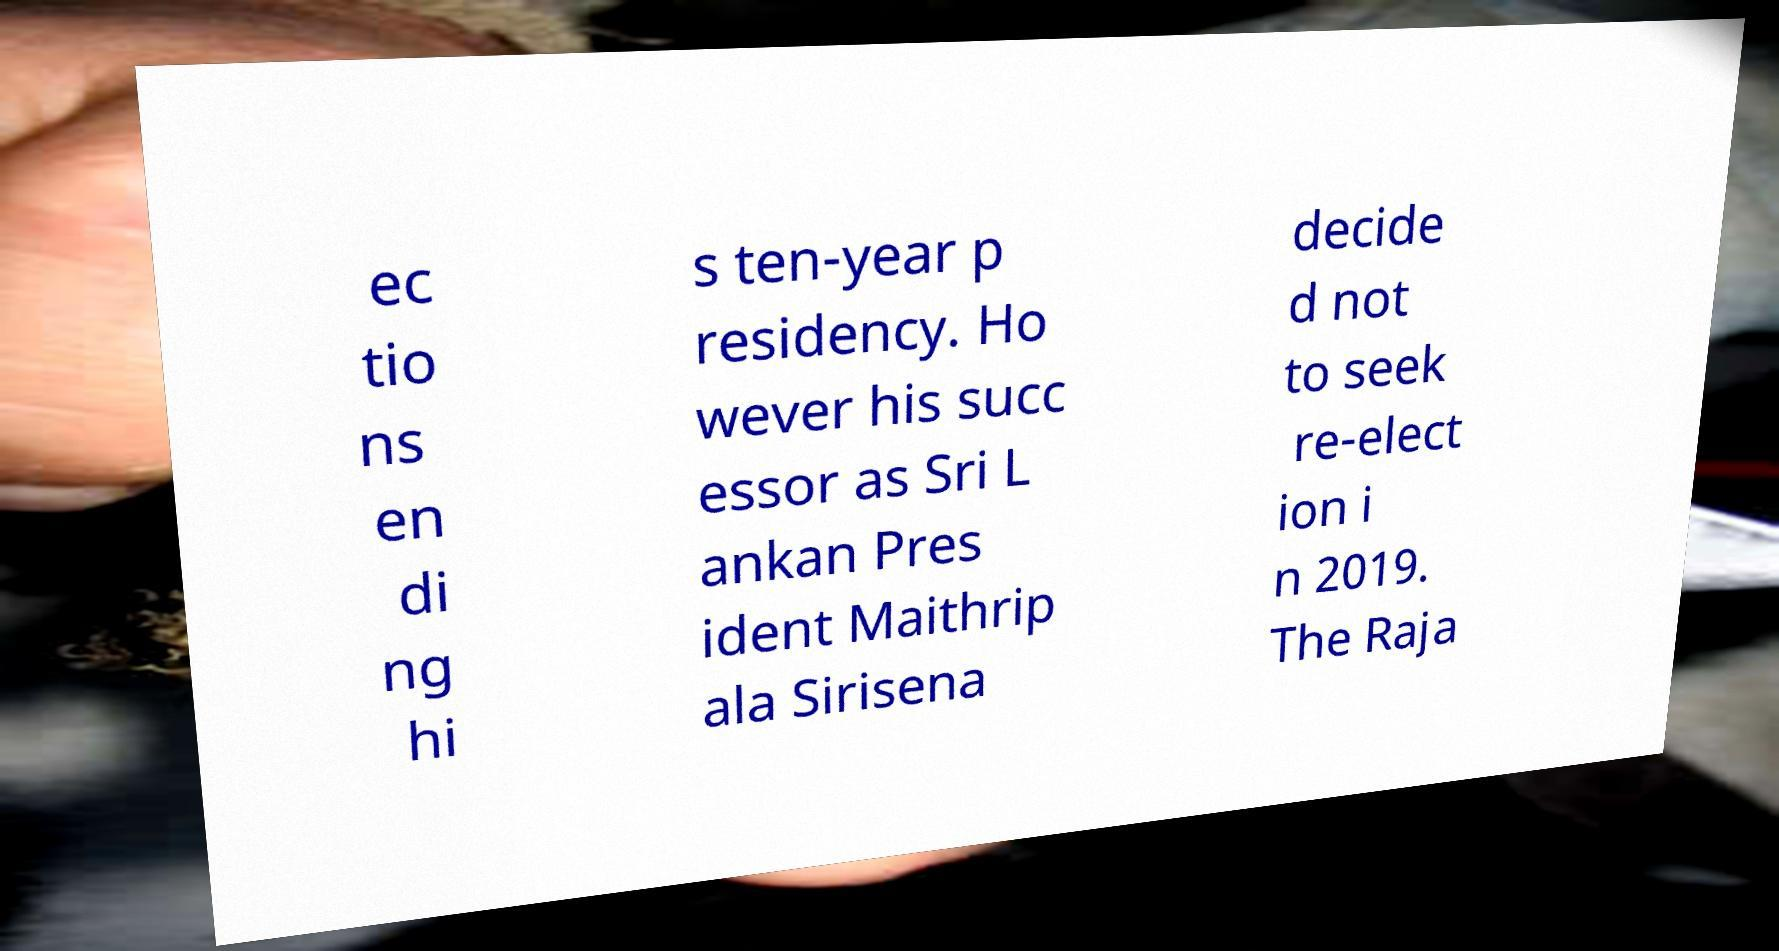There's text embedded in this image that I need extracted. Can you transcribe it verbatim? ec tio ns en di ng hi s ten-year p residency. Ho wever his succ essor as Sri L ankan Pres ident Maithrip ala Sirisena decide d not to seek re-elect ion i n 2019. The Raja 